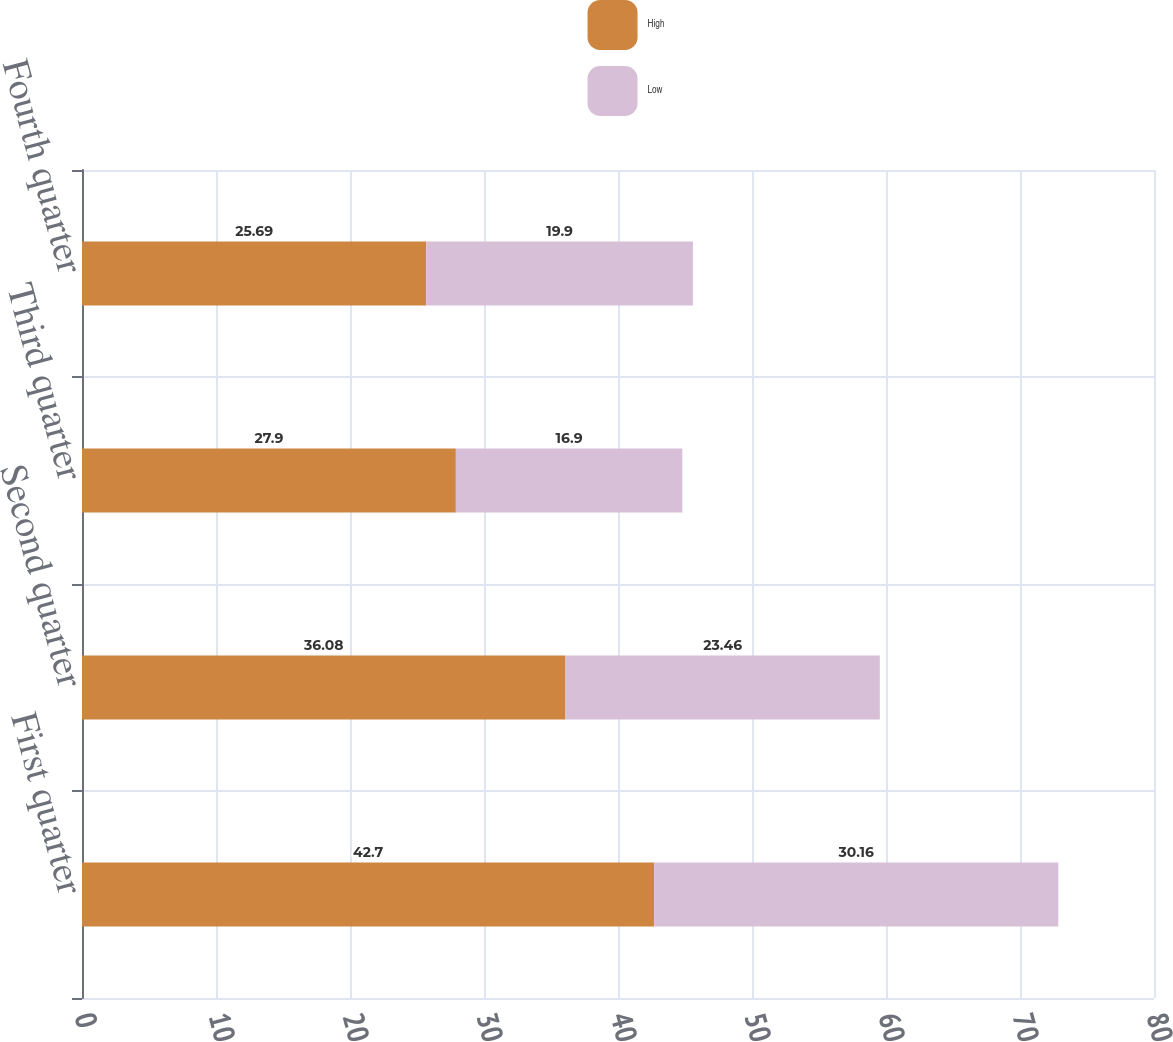<chart> <loc_0><loc_0><loc_500><loc_500><stacked_bar_chart><ecel><fcel>First quarter<fcel>Second quarter<fcel>Third quarter<fcel>Fourth quarter<nl><fcel>High<fcel>42.7<fcel>36.08<fcel>27.9<fcel>25.69<nl><fcel>Low<fcel>30.16<fcel>23.46<fcel>16.9<fcel>19.9<nl></chart> 